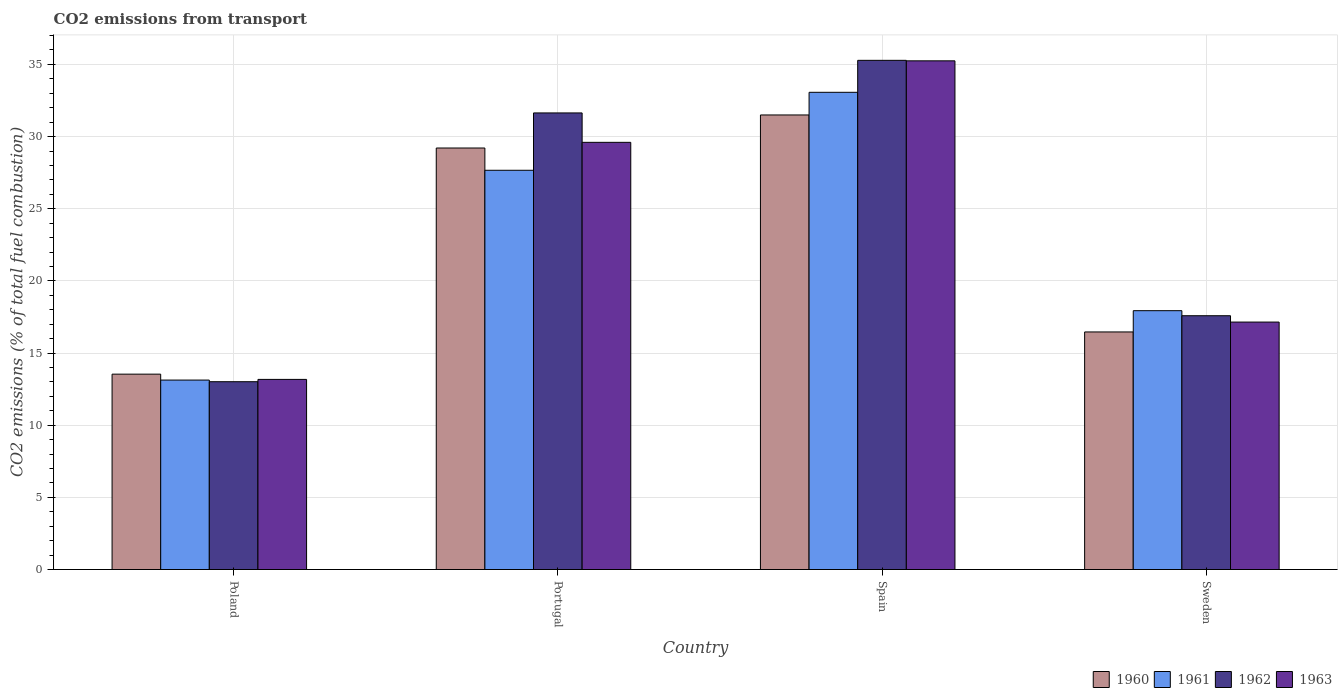How many different coloured bars are there?
Provide a succinct answer. 4. How many groups of bars are there?
Your response must be concise. 4. How many bars are there on the 3rd tick from the right?
Ensure brevity in your answer.  4. What is the label of the 2nd group of bars from the left?
Your answer should be very brief. Portugal. In how many cases, is the number of bars for a given country not equal to the number of legend labels?
Your answer should be very brief. 0. What is the total CO2 emitted in 1963 in Poland?
Your answer should be compact. 13.17. Across all countries, what is the maximum total CO2 emitted in 1962?
Provide a short and direct response. 35.28. Across all countries, what is the minimum total CO2 emitted in 1963?
Your answer should be compact. 13.17. In which country was the total CO2 emitted in 1963 minimum?
Your answer should be compact. Poland. What is the total total CO2 emitted in 1961 in the graph?
Offer a very short reply. 91.8. What is the difference between the total CO2 emitted in 1961 in Poland and that in Spain?
Your answer should be compact. -19.94. What is the difference between the total CO2 emitted in 1962 in Poland and the total CO2 emitted in 1963 in Spain?
Your response must be concise. -22.23. What is the average total CO2 emitted in 1963 per country?
Your answer should be very brief. 23.79. What is the difference between the total CO2 emitted of/in 1961 and total CO2 emitted of/in 1963 in Spain?
Offer a terse response. -2.18. What is the ratio of the total CO2 emitted in 1960 in Portugal to that in Spain?
Your answer should be very brief. 0.93. Is the total CO2 emitted in 1961 in Poland less than that in Portugal?
Your response must be concise. Yes. Is the difference between the total CO2 emitted in 1961 in Spain and Sweden greater than the difference between the total CO2 emitted in 1963 in Spain and Sweden?
Keep it short and to the point. No. What is the difference between the highest and the second highest total CO2 emitted in 1960?
Offer a very short reply. -12.75. What is the difference between the highest and the lowest total CO2 emitted in 1962?
Make the answer very short. 22.27. In how many countries, is the total CO2 emitted in 1963 greater than the average total CO2 emitted in 1963 taken over all countries?
Your answer should be compact. 2. Is the sum of the total CO2 emitted in 1963 in Portugal and Spain greater than the maximum total CO2 emitted in 1960 across all countries?
Offer a very short reply. Yes. Is it the case that in every country, the sum of the total CO2 emitted in 1963 and total CO2 emitted in 1962 is greater than the sum of total CO2 emitted in 1961 and total CO2 emitted in 1960?
Offer a very short reply. No. What does the 2nd bar from the left in Poland represents?
Your answer should be compact. 1961. What does the 2nd bar from the right in Portugal represents?
Your answer should be compact. 1962. Is it the case that in every country, the sum of the total CO2 emitted in 1960 and total CO2 emitted in 1961 is greater than the total CO2 emitted in 1963?
Provide a succinct answer. Yes. How many bars are there?
Your answer should be compact. 16. How many countries are there in the graph?
Your answer should be very brief. 4. What is the difference between two consecutive major ticks on the Y-axis?
Your answer should be very brief. 5. Are the values on the major ticks of Y-axis written in scientific E-notation?
Your answer should be compact. No. Does the graph contain any zero values?
Provide a short and direct response. No. How many legend labels are there?
Ensure brevity in your answer.  4. How are the legend labels stacked?
Provide a succinct answer. Horizontal. What is the title of the graph?
Offer a very short reply. CO2 emissions from transport. What is the label or title of the Y-axis?
Make the answer very short. CO2 emissions (% of total fuel combustion). What is the CO2 emissions (% of total fuel combustion) in 1960 in Poland?
Offer a very short reply. 13.54. What is the CO2 emissions (% of total fuel combustion) of 1961 in Poland?
Keep it short and to the point. 13.13. What is the CO2 emissions (% of total fuel combustion) in 1962 in Poland?
Provide a short and direct response. 13.01. What is the CO2 emissions (% of total fuel combustion) of 1963 in Poland?
Provide a succinct answer. 13.17. What is the CO2 emissions (% of total fuel combustion) of 1960 in Portugal?
Your answer should be very brief. 29.21. What is the CO2 emissions (% of total fuel combustion) in 1961 in Portugal?
Ensure brevity in your answer.  27.67. What is the CO2 emissions (% of total fuel combustion) of 1962 in Portugal?
Make the answer very short. 31.64. What is the CO2 emissions (% of total fuel combustion) of 1963 in Portugal?
Ensure brevity in your answer.  29.6. What is the CO2 emissions (% of total fuel combustion) of 1960 in Spain?
Make the answer very short. 31.5. What is the CO2 emissions (% of total fuel combustion) in 1961 in Spain?
Your answer should be very brief. 33.07. What is the CO2 emissions (% of total fuel combustion) in 1962 in Spain?
Make the answer very short. 35.28. What is the CO2 emissions (% of total fuel combustion) in 1963 in Spain?
Provide a succinct answer. 35.25. What is the CO2 emissions (% of total fuel combustion) of 1960 in Sweden?
Offer a terse response. 16.46. What is the CO2 emissions (% of total fuel combustion) of 1961 in Sweden?
Provide a short and direct response. 17.94. What is the CO2 emissions (% of total fuel combustion) of 1962 in Sweden?
Provide a short and direct response. 17.59. What is the CO2 emissions (% of total fuel combustion) of 1963 in Sweden?
Keep it short and to the point. 17.15. Across all countries, what is the maximum CO2 emissions (% of total fuel combustion) of 1960?
Provide a short and direct response. 31.5. Across all countries, what is the maximum CO2 emissions (% of total fuel combustion) in 1961?
Keep it short and to the point. 33.07. Across all countries, what is the maximum CO2 emissions (% of total fuel combustion) of 1962?
Provide a short and direct response. 35.28. Across all countries, what is the maximum CO2 emissions (% of total fuel combustion) in 1963?
Ensure brevity in your answer.  35.25. Across all countries, what is the minimum CO2 emissions (% of total fuel combustion) of 1960?
Provide a succinct answer. 13.54. Across all countries, what is the minimum CO2 emissions (% of total fuel combustion) of 1961?
Provide a short and direct response. 13.13. Across all countries, what is the minimum CO2 emissions (% of total fuel combustion) in 1962?
Give a very brief answer. 13.01. Across all countries, what is the minimum CO2 emissions (% of total fuel combustion) in 1963?
Give a very brief answer. 13.17. What is the total CO2 emissions (% of total fuel combustion) of 1960 in the graph?
Your answer should be compact. 90.71. What is the total CO2 emissions (% of total fuel combustion) of 1961 in the graph?
Your answer should be compact. 91.8. What is the total CO2 emissions (% of total fuel combustion) in 1962 in the graph?
Give a very brief answer. 97.52. What is the total CO2 emissions (% of total fuel combustion) in 1963 in the graph?
Offer a very short reply. 95.17. What is the difference between the CO2 emissions (% of total fuel combustion) of 1960 in Poland and that in Portugal?
Keep it short and to the point. -15.67. What is the difference between the CO2 emissions (% of total fuel combustion) of 1961 in Poland and that in Portugal?
Keep it short and to the point. -14.54. What is the difference between the CO2 emissions (% of total fuel combustion) in 1962 in Poland and that in Portugal?
Provide a succinct answer. -18.62. What is the difference between the CO2 emissions (% of total fuel combustion) of 1963 in Poland and that in Portugal?
Provide a short and direct response. -16.43. What is the difference between the CO2 emissions (% of total fuel combustion) of 1960 in Poland and that in Spain?
Make the answer very short. -17.96. What is the difference between the CO2 emissions (% of total fuel combustion) in 1961 in Poland and that in Spain?
Offer a very short reply. -19.94. What is the difference between the CO2 emissions (% of total fuel combustion) in 1962 in Poland and that in Spain?
Ensure brevity in your answer.  -22.27. What is the difference between the CO2 emissions (% of total fuel combustion) of 1963 in Poland and that in Spain?
Your answer should be compact. -22.07. What is the difference between the CO2 emissions (% of total fuel combustion) of 1960 in Poland and that in Sweden?
Give a very brief answer. -2.92. What is the difference between the CO2 emissions (% of total fuel combustion) in 1961 in Poland and that in Sweden?
Give a very brief answer. -4.81. What is the difference between the CO2 emissions (% of total fuel combustion) in 1962 in Poland and that in Sweden?
Your answer should be compact. -4.57. What is the difference between the CO2 emissions (% of total fuel combustion) of 1963 in Poland and that in Sweden?
Give a very brief answer. -3.97. What is the difference between the CO2 emissions (% of total fuel combustion) of 1960 in Portugal and that in Spain?
Your response must be concise. -2.29. What is the difference between the CO2 emissions (% of total fuel combustion) in 1961 in Portugal and that in Spain?
Make the answer very short. -5.4. What is the difference between the CO2 emissions (% of total fuel combustion) of 1962 in Portugal and that in Spain?
Offer a very short reply. -3.64. What is the difference between the CO2 emissions (% of total fuel combustion) in 1963 in Portugal and that in Spain?
Make the answer very short. -5.65. What is the difference between the CO2 emissions (% of total fuel combustion) in 1960 in Portugal and that in Sweden?
Provide a short and direct response. 12.75. What is the difference between the CO2 emissions (% of total fuel combustion) in 1961 in Portugal and that in Sweden?
Provide a succinct answer. 9.73. What is the difference between the CO2 emissions (% of total fuel combustion) of 1962 in Portugal and that in Sweden?
Offer a terse response. 14.05. What is the difference between the CO2 emissions (% of total fuel combustion) in 1963 in Portugal and that in Sweden?
Provide a succinct answer. 12.45. What is the difference between the CO2 emissions (% of total fuel combustion) of 1960 in Spain and that in Sweden?
Ensure brevity in your answer.  15.04. What is the difference between the CO2 emissions (% of total fuel combustion) in 1961 in Spain and that in Sweden?
Provide a short and direct response. 15.13. What is the difference between the CO2 emissions (% of total fuel combustion) of 1962 in Spain and that in Sweden?
Your answer should be compact. 17.7. What is the difference between the CO2 emissions (% of total fuel combustion) of 1963 in Spain and that in Sweden?
Give a very brief answer. 18.1. What is the difference between the CO2 emissions (% of total fuel combustion) of 1960 in Poland and the CO2 emissions (% of total fuel combustion) of 1961 in Portugal?
Offer a very short reply. -14.13. What is the difference between the CO2 emissions (% of total fuel combustion) in 1960 in Poland and the CO2 emissions (% of total fuel combustion) in 1962 in Portugal?
Offer a very short reply. -18.1. What is the difference between the CO2 emissions (% of total fuel combustion) in 1960 in Poland and the CO2 emissions (% of total fuel combustion) in 1963 in Portugal?
Offer a very short reply. -16.06. What is the difference between the CO2 emissions (% of total fuel combustion) in 1961 in Poland and the CO2 emissions (% of total fuel combustion) in 1962 in Portugal?
Your answer should be very brief. -18.51. What is the difference between the CO2 emissions (% of total fuel combustion) of 1961 in Poland and the CO2 emissions (% of total fuel combustion) of 1963 in Portugal?
Your response must be concise. -16.47. What is the difference between the CO2 emissions (% of total fuel combustion) in 1962 in Poland and the CO2 emissions (% of total fuel combustion) in 1963 in Portugal?
Make the answer very short. -16.59. What is the difference between the CO2 emissions (% of total fuel combustion) in 1960 in Poland and the CO2 emissions (% of total fuel combustion) in 1961 in Spain?
Provide a short and direct response. -19.53. What is the difference between the CO2 emissions (% of total fuel combustion) of 1960 in Poland and the CO2 emissions (% of total fuel combustion) of 1962 in Spain?
Keep it short and to the point. -21.75. What is the difference between the CO2 emissions (% of total fuel combustion) of 1960 in Poland and the CO2 emissions (% of total fuel combustion) of 1963 in Spain?
Your answer should be very brief. -21.71. What is the difference between the CO2 emissions (% of total fuel combustion) in 1961 in Poland and the CO2 emissions (% of total fuel combustion) in 1962 in Spain?
Ensure brevity in your answer.  -22.16. What is the difference between the CO2 emissions (% of total fuel combustion) in 1961 in Poland and the CO2 emissions (% of total fuel combustion) in 1963 in Spain?
Your answer should be compact. -22.12. What is the difference between the CO2 emissions (% of total fuel combustion) in 1962 in Poland and the CO2 emissions (% of total fuel combustion) in 1963 in Spain?
Keep it short and to the point. -22.23. What is the difference between the CO2 emissions (% of total fuel combustion) in 1960 in Poland and the CO2 emissions (% of total fuel combustion) in 1961 in Sweden?
Keep it short and to the point. -4.4. What is the difference between the CO2 emissions (% of total fuel combustion) of 1960 in Poland and the CO2 emissions (% of total fuel combustion) of 1962 in Sweden?
Your response must be concise. -4.05. What is the difference between the CO2 emissions (% of total fuel combustion) in 1960 in Poland and the CO2 emissions (% of total fuel combustion) in 1963 in Sweden?
Provide a succinct answer. -3.61. What is the difference between the CO2 emissions (% of total fuel combustion) of 1961 in Poland and the CO2 emissions (% of total fuel combustion) of 1962 in Sweden?
Ensure brevity in your answer.  -4.46. What is the difference between the CO2 emissions (% of total fuel combustion) of 1961 in Poland and the CO2 emissions (% of total fuel combustion) of 1963 in Sweden?
Offer a very short reply. -4.02. What is the difference between the CO2 emissions (% of total fuel combustion) in 1962 in Poland and the CO2 emissions (% of total fuel combustion) in 1963 in Sweden?
Offer a terse response. -4.13. What is the difference between the CO2 emissions (% of total fuel combustion) of 1960 in Portugal and the CO2 emissions (% of total fuel combustion) of 1961 in Spain?
Your answer should be compact. -3.86. What is the difference between the CO2 emissions (% of total fuel combustion) of 1960 in Portugal and the CO2 emissions (% of total fuel combustion) of 1962 in Spain?
Your answer should be very brief. -6.08. What is the difference between the CO2 emissions (% of total fuel combustion) of 1960 in Portugal and the CO2 emissions (% of total fuel combustion) of 1963 in Spain?
Make the answer very short. -6.04. What is the difference between the CO2 emissions (% of total fuel combustion) of 1961 in Portugal and the CO2 emissions (% of total fuel combustion) of 1962 in Spain?
Give a very brief answer. -7.62. What is the difference between the CO2 emissions (% of total fuel combustion) of 1961 in Portugal and the CO2 emissions (% of total fuel combustion) of 1963 in Spain?
Provide a short and direct response. -7.58. What is the difference between the CO2 emissions (% of total fuel combustion) of 1962 in Portugal and the CO2 emissions (% of total fuel combustion) of 1963 in Spain?
Give a very brief answer. -3.61. What is the difference between the CO2 emissions (% of total fuel combustion) of 1960 in Portugal and the CO2 emissions (% of total fuel combustion) of 1961 in Sweden?
Your answer should be very brief. 11.27. What is the difference between the CO2 emissions (% of total fuel combustion) in 1960 in Portugal and the CO2 emissions (% of total fuel combustion) in 1962 in Sweden?
Your response must be concise. 11.62. What is the difference between the CO2 emissions (% of total fuel combustion) of 1960 in Portugal and the CO2 emissions (% of total fuel combustion) of 1963 in Sweden?
Give a very brief answer. 12.06. What is the difference between the CO2 emissions (% of total fuel combustion) in 1961 in Portugal and the CO2 emissions (% of total fuel combustion) in 1962 in Sweden?
Give a very brief answer. 10.08. What is the difference between the CO2 emissions (% of total fuel combustion) of 1961 in Portugal and the CO2 emissions (% of total fuel combustion) of 1963 in Sweden?
Keep it short and to the point. 10.52. What is the difference between the CO2 emissions (% of total fuel combustion) in 1962 in Portugal and the CO2 emissions (% of total fuel combustion) in 1963 in Sweden?
Offer a terse response. 14.49. What is the difference between the CO2 emissions (% of total fuel combustion) in 1960 in Spain and the CO2 emissions (% of total fuel combustion) in 1961 in Sweden?
Your answer should be very brief. 13.56. What is the difference between the CO2 emissions (% of total fuel combustion) in 1960 in Spain and the CO2 emissions (% of total fuel combustion) in 1962 in Sweden?
Your response must be concise. 13.91. What is the difference between the CO2 emissions (% of total fuel combustion) of 1960 in Spain and the CO2 emissions (% of total fuel combustion) of 1963 in Sweden?
Offer a terse response. 14.35. What is the difference between the CO2 emissions (% of total fuel combustion) of 1961 in Spain and the CO2 emissions (% of total fuel combustion) of 1962 in Sweden?
Make the answer very short. 15.48. What is the difference between the CO2 emissions (% of total fuel combustion) in 1961 in Spain and the CO2 emissions (% of total fuel combustion) in 1963 in Sweden?
Ensure brevity in your answer.  15.92. What is the difference between the CO2 emissions (% of total fuel combustion) in 1962 in Spain and the CO2 emissions (% of total fuel combustion) in 1963 in Sweden?
Provide a succinct answer. 18.14. What is the average CO2 emissions (% of total fuel combustion) in 1960 per country?
Your answer should be compact. 22.68. What is the average CO2 emissions (% of total fuel combustion) in 1961 per country?
Offer a terse response. 22.95. What is the average CO2 emissions (% of total fuel combustion) in 1962 per country?
Give a very brief answer. 24.38. What is the average CO2 emissions (% of total fuel combustion) in 1963 per country?
Make the answer very short. 23.79. What is the difference between the CO2 emissions (% of total fuel combustion) of 1960 and CO2 emissions (% of total fuel combustion) of 1961 in Poland?
Your answer should be very brief. 0.41. What is the difference between the CO2 emissions (% of total fuel combustion) of 1960 and CO2 emissions (% of total fuel combustion) of 1962 in Poland?
Make the answer very short. 0.52. What is the difference between the CO2 emissions (% of total fuel combustion) of 1960 and CO2 emissions (% of total fuel combustion) of 1963 in Poland?
Ensure brevity in your answer.  0.36. What is the difference between the CO2 emissions (% of total fuel combustion) in 1961 and CO2 emissions (% of total fuel combustion) in 1962 in Poland?
Make the answer very short. 0.11. What is the difference between the CO2 emissions (% of total fuel combustion) in 1961 and CO2 emissions (% of total fuel combustion) in 1963 in Poland?
Give a very brief answer. -0.05. What is the difference between the CO2 emissions (% of total fuel combustion) of 1962 and CO2 emissions (% of total fuel combustion) of 1963 in Poland?
Your answer should be compact. -0.16. What is the difference between the CO2 emissions (% of total fuel combustion) of 1960 and CO2 emissions (% of total fuel combustion) of 1961 in Portugal?
Your response must be concise. 1.54. What is the difference between the CO2 emissions (% of total fuel combustion) in 1960 and CO2 emissions (% of total fuel combustion) in 1962 in Portugal?
Make the answer very short. -2.43. What is the difference between the CO2 emissions (% of total fuel combustion) of 1960 and CO2 emissions (% of total fuel combustion) of 1963 in Portugal?
Your answer should be very brief. -0.39. What is the difference between the CO2 emissions (% of total fuel combustion) of 1961 and CO2 emissions (% of total fuel combustion) of 1962 in Portugal?
Give a very brief answer. -3.97. What is the difference between the CO2 emissions (% of total fuel combustion) in 1961 and CO2 emissions (% of total fuel combustion) in 1963 in Portugal?
Provide a succinct answer. -1.94. What is the difference between the CO2 emissions (% of total fuel combustion) of 1962 and CO2 emissions (% of total fuel combustion) of 1963 in Portugal?
Your response must be concise. 2.04. What is the difference between the CO2 emissions (% of total fuel combustion) in 1960 and CO2 emissions (% of total fuel combustion) in 1961 in Spain?
Give a very brief answer. -1.57. What is the difference between the CO2 emissions (% of total fuel combustion) in 1960 and CO2 emissions (% of total fuel combustion) in 1962 in Spain?
Your answer should be compact. -3.78. What is the difference between the CO2 emissions (% of total fuel combustion) in 1960 and CO2 emissions (% of total fuel combustion) in 1963 in Spain?
Ensure brevity in your answer.  -3.75. What is the difference between the CO2 emissions (% of total fuel combustion) of 1961 and CO2 emissions (% of total fuel combustion) of 1962 in Spain?
Your answer should be compact. -2.22. What is the difference between the CO2 emissions (% of total fuel combustion) of 1961 and CO2 emissions (% of total fuel combustion) of 1963 in Spain?
Give a very brief answer. -2.18. What is the difference between the CO2 emissions (% of total fuel combustion) in 1962 and CO2 emissions (% of total fuel combustion) in 1963 in Spain?
Ensure brevity in your answer.  0.04. What is the difference between the CO2 emissions (% of total fuel combustion) in 1960 and CO2 emissions (% of total fuel combustion) in 1961 in Sweden?
Give a very brief answer. -1.47. What is the difference between the CO2 emissions (% of total fuel combustion) of 1960 and CO2 emissions (% of total fuel combustion) of 1962 in Sweden?
Your answer should be very brief. -1.12. What is the difference between the CO2 emissions (% of total fuel combustion) of 1960 and CO2 emissions (% of total fuel combustion) of 1963 in Sweden?
Your answer should be compact. -0.69. What is the difference between the CO2 emissions (% of total fuel combustion) in 1961 and CO2 emissions (% of total fuel combustion) in 1962 in Sweden?
Provide a succinct answer. 0.35. What is the difference between the CO2 emissions (% of total fuel combustion) of 1961 and CO2 emissions (% of total fuel combustion) of 1963 in Sweden?
Ensure brevity in your answer.  0.79. What is the difference between the CO2 emissions (% of total fuel combustion) in 1962 and CO2 emissions (% of total fuel combustion) in 1963 in Sweden?
Offer a terse response. 0.44. What is the ratio of the CO2 emissions (% of total fuel combustion) of 1960 in Poland to that in Portugal?
Offer a terse response. 0.46. What is the ratio of the CO2 emissions (% of total fuel combustion) of 1961 in Poland to that in Portugal?
Provide a succinct answer. 0.47. What is the ratio of the CO2 emissions (% of total fuel combustion) of 1962 in Poland to that in Portugal?
Give a very brief answer. 0.41. What is the ratio of the CO2 emissions (% of total fuel combustion) in 1963 in Poland to that in Portugal?
Provide a short and direct response. 0.45. What is the ratio of the CO2 emissions (% of total fuel combustion) in 1960 in Poland to that in Spain?
Ensure brevity in your answer.  0.43. What is the ratio of the CO2 emissions (% of total fuel combustion) in 1961 in Poland to that in Spain?
Make the answer very short. 0.4. What is the ratio of the CO2 emissions (% of total fuel combustion) of 1962 in Poland to that in Spain?
Provide a short and direct response. 0.37. What is the ratio of the CO2 emissions (% of total fuel combustion) of 1963 in Poland to that in Spain?
Your answer should be compact. 0.37. What is the ratio of the CO2 emissions (% of total fuel combustion) in 1960 in Poland to that in Sweden?
Offer a terse response. 0.82. What is the ratio of the CO2 emissions (% of total fuel combustion) in 1961 in Poland to that in Sweden?
Offer a terse response. 0.73. What is the ratio of the CO2 emissions (% of total fuel combustion) in 1962 in Poland to that in Sweden?
Your answer should be very brief. 0.74. What is the ratio of the CO2 emissions (% of total fuel combustion) of 1963 in Poland to that in Sweden?
Ensure brevity in your answer.  0.77. What is the ratio of the CO2 emissions (% of total fuel combustion) of 1960 in Portugal to that in Spain?
Offer a very short reply. 0.93. What is the ratio of the CO2 emissions (% of total fuel combustion) in 1961 in Portugal to that in Spain?
Provide a succinct answer. 0.84. What is the ratio of the CO2 emissions (% of total fuel combustion) of 1962 in Portugal to that in Spain?
Offer a very short reply. 0.9. What is the ratio of the CO2 emissions (% of total fuel combustion) of 1963 in Portugal to that in Spain?
Give a very brief answer. 0.84. What is the ratio of the CO2 emissions (% of total fuel combustion) of 1960 in Portugal to that in Sweden?
Your answer should be compact. 1.77. What is the ratio of the CO2 emissions (% of total fuel combustion) in 1961 in Portugal to that in Sweden?
Your response must be concise. 1.54. What is the ratio of the CO2 emissions (% of total fuel combustion) in 1962 in Portugal to that in Sweden?
Provide a succinct answer. 1.8. What is the ratio of the CO2 emissions (% of total fuel combustion) in 1963 in Portugal to that in Sweden?
Ensure brevity in your answer.  1.73. What is the ratio of the CO2 emissions (% of total fuel combustion) in 1960 in Spain to that in Sweden?
Your answer should be compact. 1.91. What is the ratio of the CO2 emissions (% of total fuel combustion) of 1961 in Spain to that in Sweden?
Your answer should be compact. 1.84. What is the ratio of the CO2 emissions (% of total fuel combustion) in 1962 in Spain to that in Sweden?
Provide a short and direct response. 2.01. What is the ratio of the CO2 emissions (% of total fuel combustion) of 1963 in Spain to that in Sweden?
Make the answer very short. 2.06. What is the difference between the highest and the second highest CO2 emissions (% of total fuel combustion) of 1960?
Offer a very short reply. 2.29. What is the difference between the highest and the second highest CO2 emissions (% of total fuel combustion) in 1961?
Your answer should be compact. 5.4. What is the difference between the highest and the second highest CO2 emissions (% of total fuel combustion) of 1962?
Give a very brief answer. 3.64. What is the difference between the highest and the second highest CO2 emissions (% of total fuel combustion) in 1963?
Your response must be concise. 5.65. What is the difference between the highest and the lowest CO2 emissions (% of total fuel combustion) in 1960?
Provide a short and direct response. 17.96. What is the difference between the highest and the lowest CO2 emissions (% of total fuel combustion) in 1961?
Give a very brief answer. 19.94. What is the difference between the highest and the lowest CO2 emissions (% of total fuel combustion) of 1962?
Offer a terse response. 22.27. What is the difference between the highest and the lowest CO2 emissions (% of total fuel combustion) of 1963?
Offer a terse response. 22.07. 